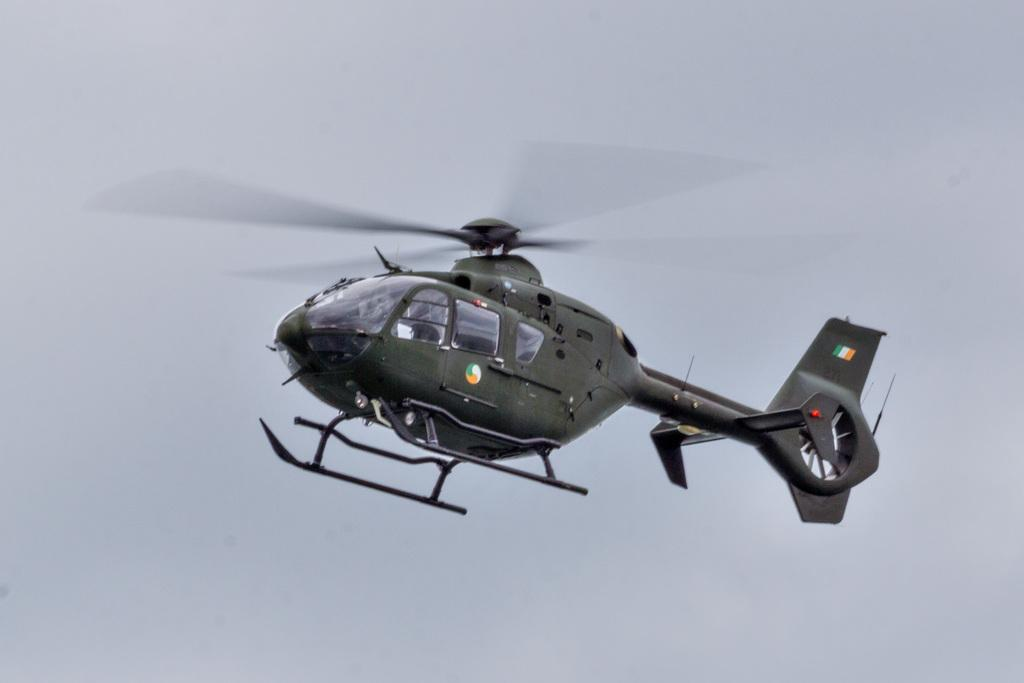What is the main subject of the image? The main subject of the image is a helicopter. Can you describe the position of the helicopter in the image? The helicopter is in the air in the image. What can be seen in the background of the image? There is sky visible in the background of the image. Can you tell me how many dogs are sitting on the boat in the image? There is no boat or dog present in the image; it features a helicopter in the air. 